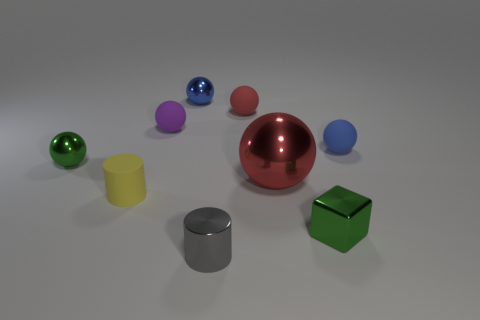Are the shadows consistent with a single light source? Yes, the shadows cast by the objects on the ground are consistent with a single light source. They extend away from the objects in a direction opposite to where the light is assumed to be originating, indicating coherent lighting within the scene. 